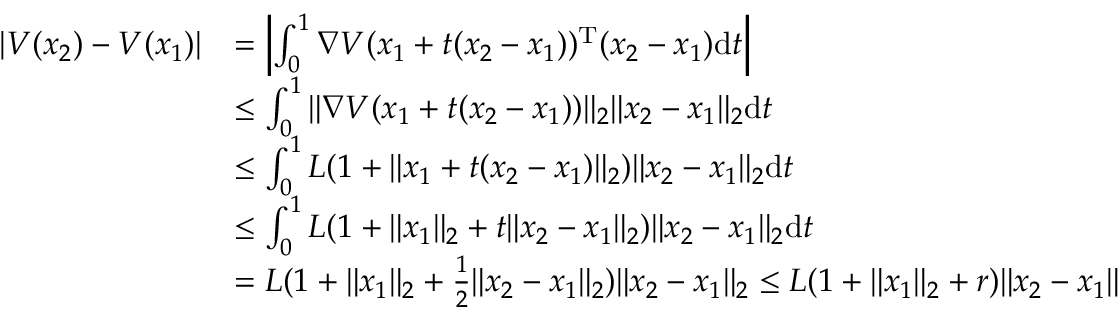<formula> <loc_0><loc_0><loc_500><loc_500>\begin{array} { r l } { | V ( x _ { 2 } ) - V ( x _ { 1 } ) | } & { = \left | \int _ { 0 } ^ { 1 } \nabla V ( x _ { 1 } + t ( x _ { 2 } - x _ { 1 } ) ) ^ { T } ( x _ { 2 } - x _ { 1 } ) d t \right | } \\ & { \leq \int _ { 0 } ^ { 1 } \| \nabla V ( x _ { 1 } + t ( x _ { 2 } - x _ { 1 } ) ) \| _ { 2 } \| x _ { 2 } - x _ { 1 } \| _ { 2 } d t } \\ & { \leq \int _ { 0 } ^ { 1 } L ( 1 + \| x _ { 1 } + t ( x _ { 2 } - x _ { 1 } ) \| _ { 2 } ) \| x _ { 2 } - x _ { 1 } \| _ { 2 } d t } \\ & { \leq \int _ { 0 } ^ { 1 } L ( 1 + \| x _ { 1 } \| _ { 2 } + t \| x _ { 2 } - x _ { 1 } \| _ { 2 } ) \| x _ { 2 } - x _ { 1 } \| _ { 2 } d t } \\ & { = L ( 1 + \| x _ { 1 } \| _ { 2 } + \frac { 1 } { 2 } \| x _ { 2 } - x _ { 1 } \| _ { 2 } ) \| x _ { 2 } - x _ { 1 } \| _ { 2 } \leq L ( 1 + \| x _ { 1 } \| _ { 2 } + r ) \| x _ { 2 } - x _ { 1 } \| } \end{array}</formula> 